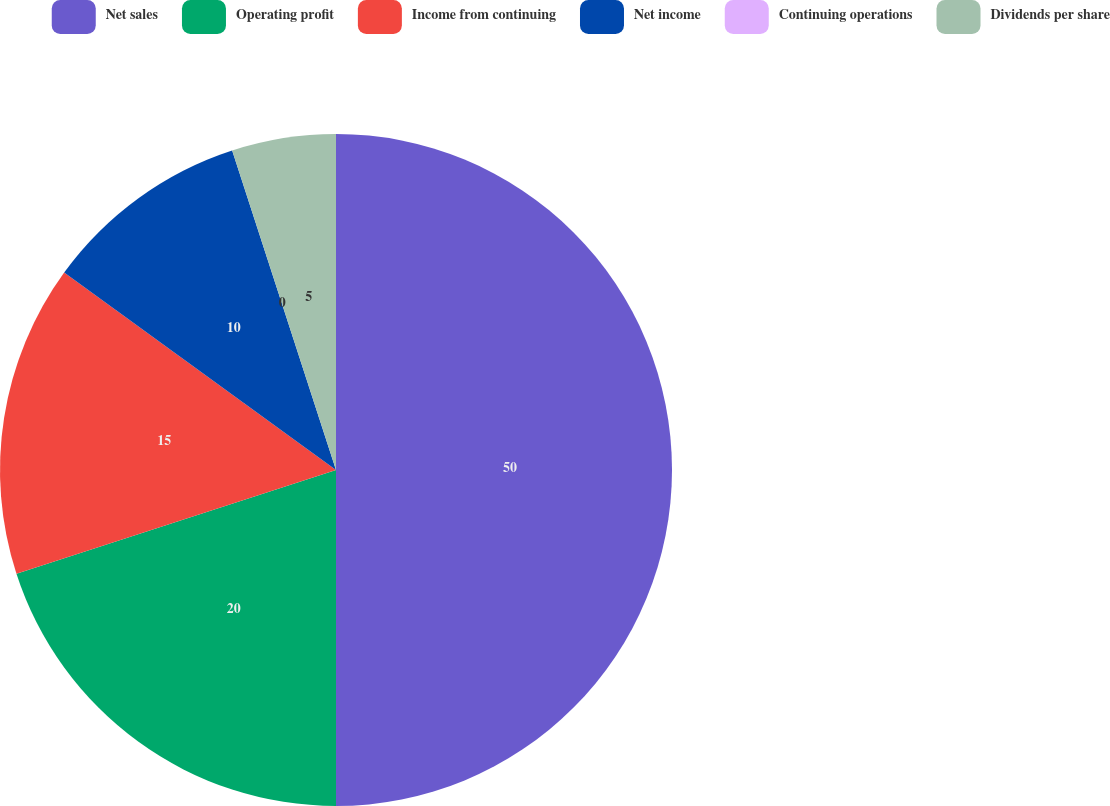<chart> <loc_0><loc_0><loc_500><loc_500><pie_chart><fcel>Net sales<fcel>Operating profit<fcel>Income from continuing<fcel>Net income<fcel>Continuing operations<fcel>Dividends per share<nl><fcel>50.0%<fcel>20.0%<fcel>15.0%<fcel>10.0%<fcel>0.0%<fcel>5.0%<nl></chart> 